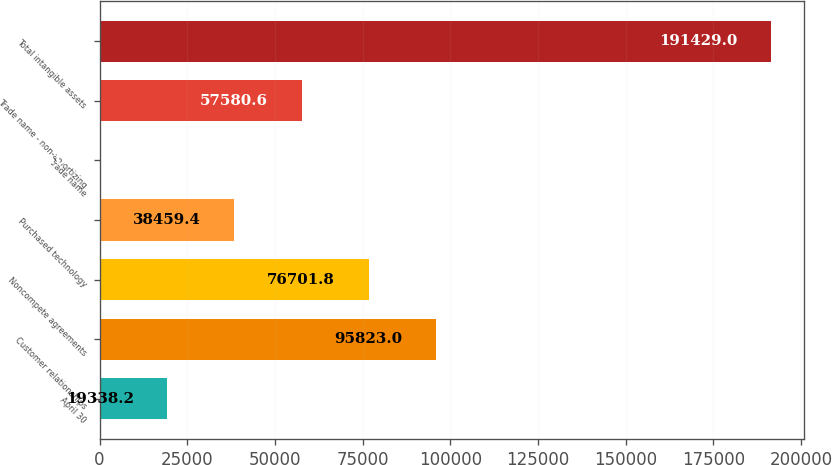<chart> <loc_0><loc_0><loc_500><loc_500><bar_chart><fcel>April 30<fcel>Customer relationships<fcel>Noncompete agreements<fcel>Purchased technology<fcel>Trade name<fcel>Trade name - non-amortizing<fcel>Total intangible assets<nl><fcel>19338.2<fcel>95823<fcel>76701.8<fcel>38459.4<fcel>217<fcel>57580.6<fcel>191429<nl></chart> 